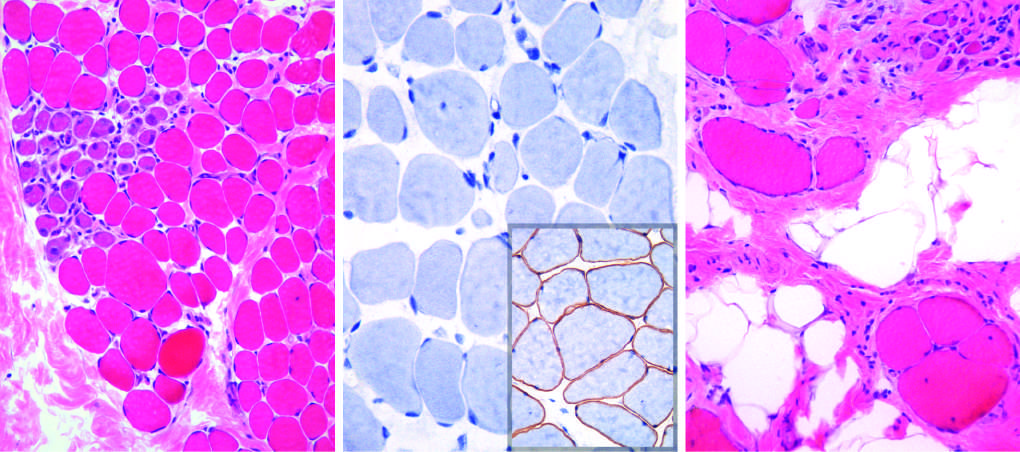do myofibers show variation in size?
Answer the question using a single word or phrase. Yes 